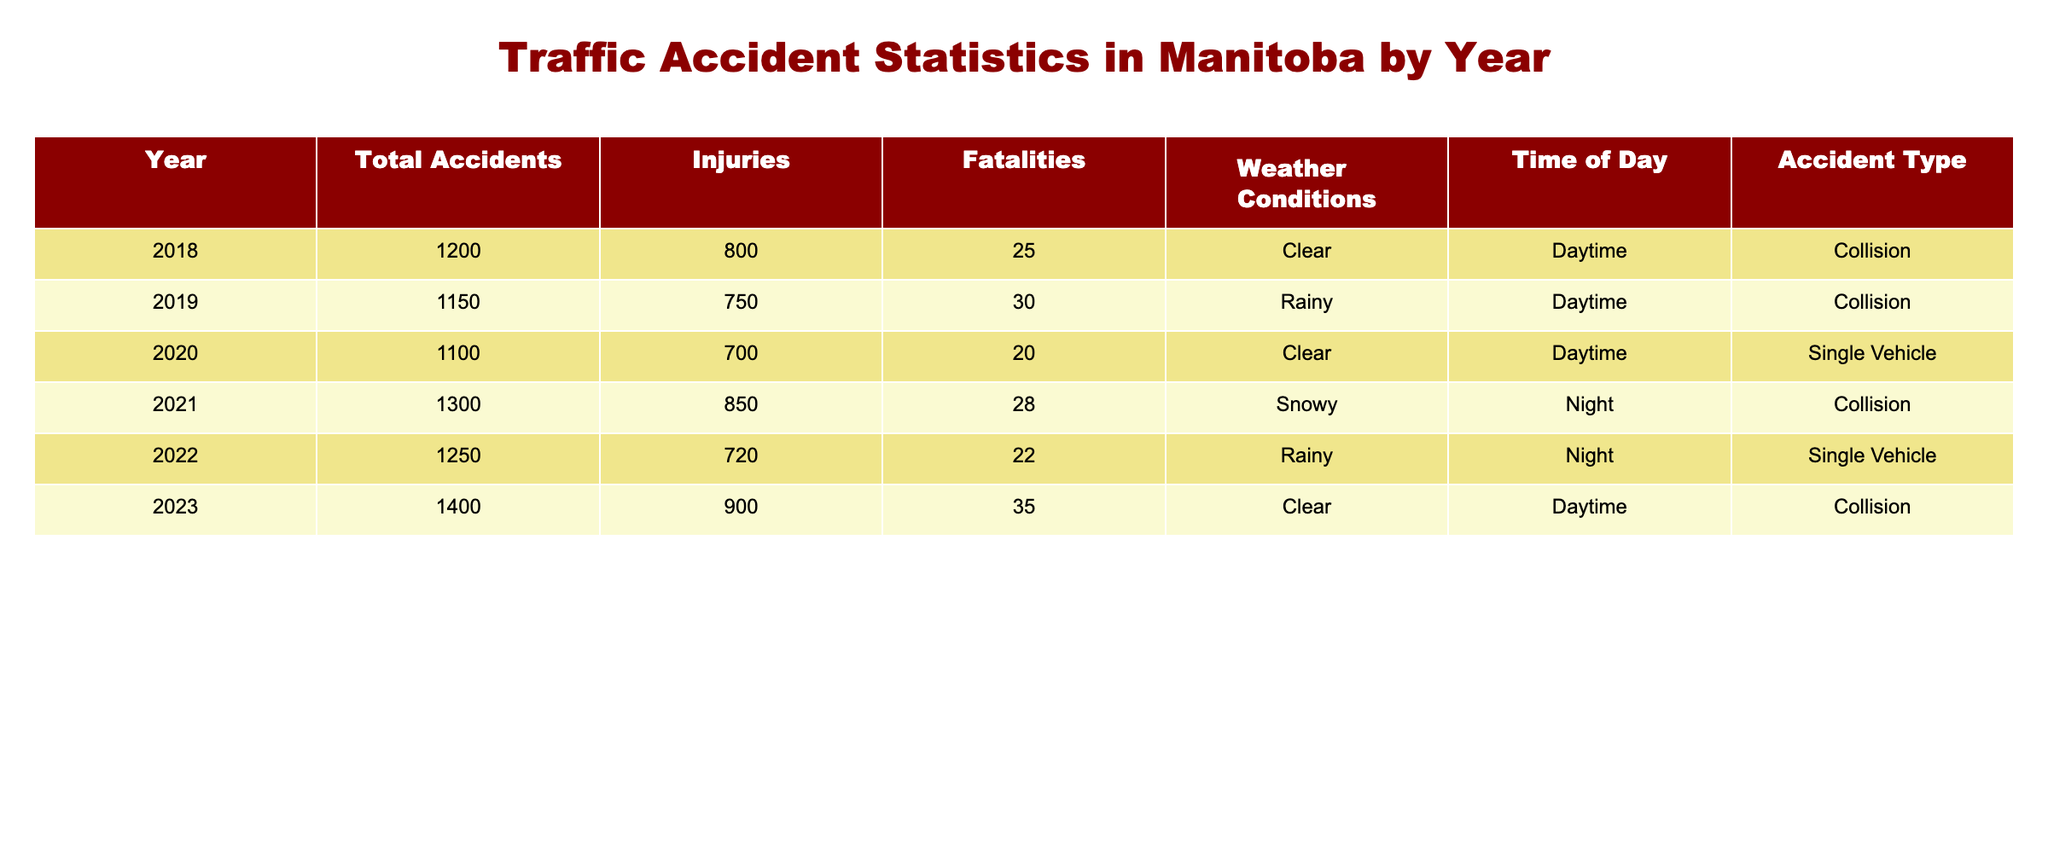What year had the highest number of total accidents? Looking at the "Total Accidents" column, the years listed from 2018 to 2023 show that 2023 has the highest total of 1400 accidents.
Answer: 2023 How many fatalities were recorded in 2021? Directly checking the "Fatalities" column for the year 2021, we see that it lists 28 fatalities.
Answer: 28 What is the difference in injuries between 2019 and 2022? From the "Injuries" column, 2019 recorded 750 injuries and 2022 recorded 720 injuries. The difference is 750 - 720 = 30.
Answer: 30 Was the weather condition "Clear" reported in both 2020 and 2023? Checking the "Weather Conditions" column, we find "Clear" in both 2020 and 2023, confirming that it was reported in both years.
Answer: Yes What was the average number of fatalities from 2018 to 2023? First, add the fatalities for the years 2018 (25), 2019 (30), 2020 (20), 2021 (28), 2022 (22), and 2023 (35), which totals to 25 + 30 + 20 + 28 + 22 + 35 = 160. There are 6 years, so the average is 160/6 = 26.67.
Answer: 26.67 How many accidents occurred at night in 2021? Referring to the "Time of Day" column for 2021, we see that the accidents recorded occurred at night, with a total of 1300 accidents during that year.
Answer: 1300 What was the total number of accidents due to "Single Vehicle" accidents from 2018 to 2023? Checking the "Accident Type" column, we find "Single Vehicle" incidents in 2020 (1100) and 2022 (1250). We add these two totals: 1100 + 1250 = 2350.
Answer: 2350 Did the total number of accidents increase from 2018 to 2023? Comparing the "Total Accidents" from 2018 (1200) to 2023 (1400), we see that 1400 is greater than 1200, confirming an increase.
Answer: Yes What is the ratio of total accidents in 2020 to total accidents in 2021? The total accidents for 2020 are 1100 and for 2021 are 1300. The ratio is 1100:1300 or simplified, 11:13.
Answer: 11:13 